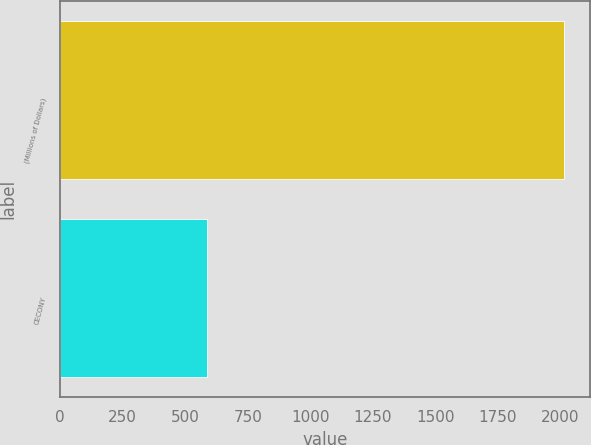Convert chart to OTSL. <chart><loc_0><loc_0><loc_500><loc_500><bar_chart><fcel>(Millions of Dollars)<fcel>CECONY<nl><fcel>2016<fcel>586<nl></chart> 